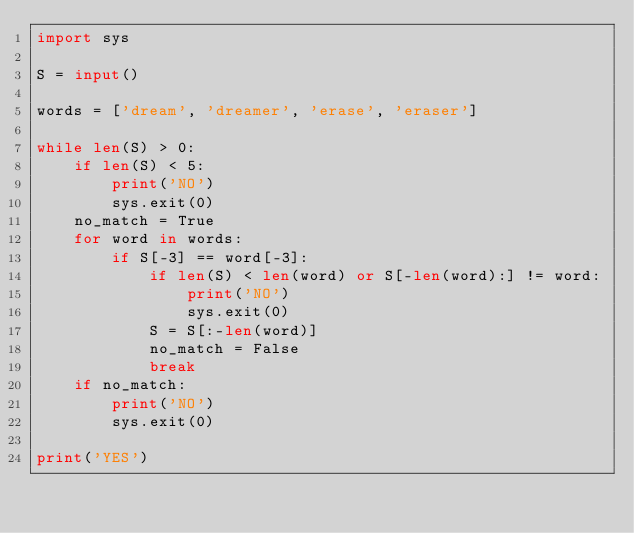<code> <loc_0><loc_0><loc_500><loc_500><_Python_>import sys

S = input()

words = ['dream', 'dreamer', 'erase', 'eraser']

while len(S) > 0:
    if len(S) < 5:
        print('NO')
        sys.exit(0)
    no_match = True
    for word in words:
        if S[-3] == word[-3]:
            if len(S) < len(word) or S[-len(word):] != word:
                print('NO')
                sys.exit(0)
            S = S[:-len(word)]
            no_match = False
            break
    if no_match:
        print('NO')
        sys.exit(0)

print('YES')</code> 